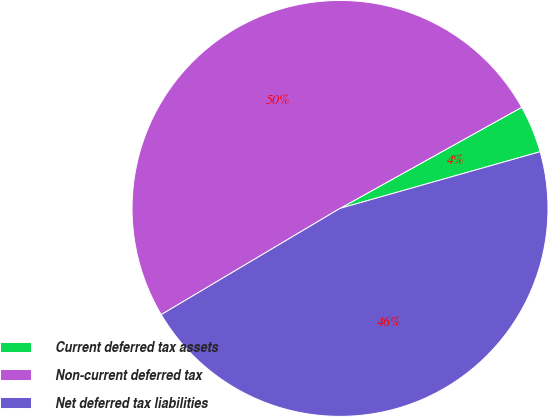Convert chart. <chart><loc_0><loc_0><loc_500><loc_500><pie_chart><fcel>Current deferred tax assets<fcel>Non-current deferred tax<fcel>Net deferred tax liabilities<nl><fcel>3.69%<fcel>50.45%<fcel>45.86%<nl></chart> 